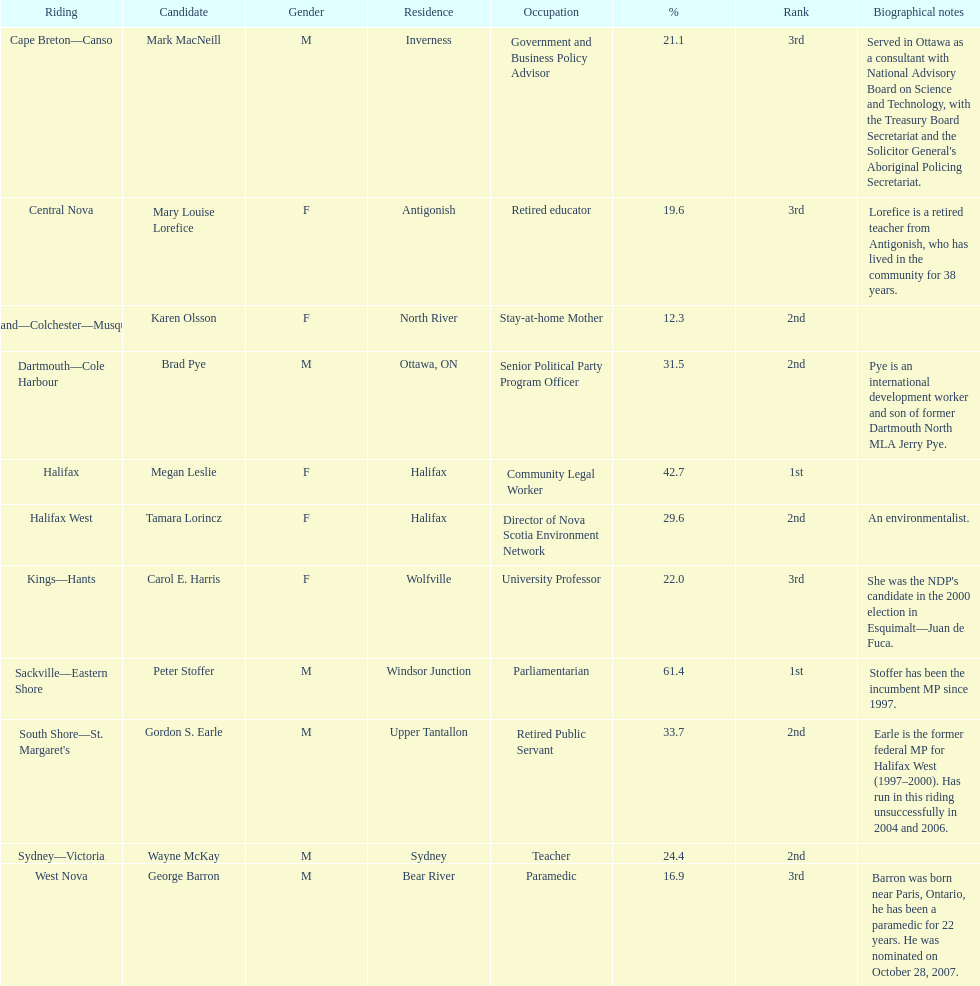How many candidates were women? 5. 